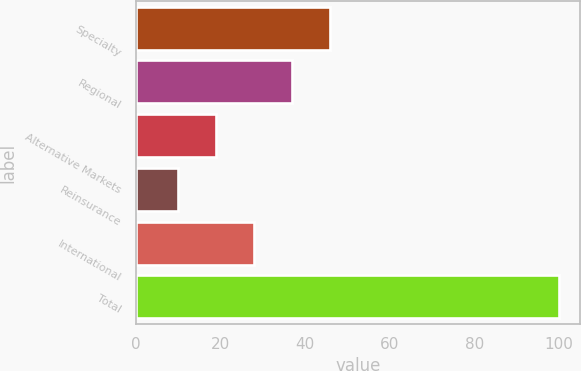<chart> <loc_0><loc_0><loc_500><loc_500><bar_chart><fcel>Specialty<fcel>Regional<fcel>Alternative Markets<fcel>Reinsurance<fcel>International<fcel>Total<nl><fcel>45.94<fcel>36.93<fcel>18.91<fcel>9.9<fcel>27.92<fcel>100<nl></chart> 